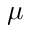Convert formula to latex. <formula><loc_0><loc_0><loc_500><loc_500>\mu</formula> 